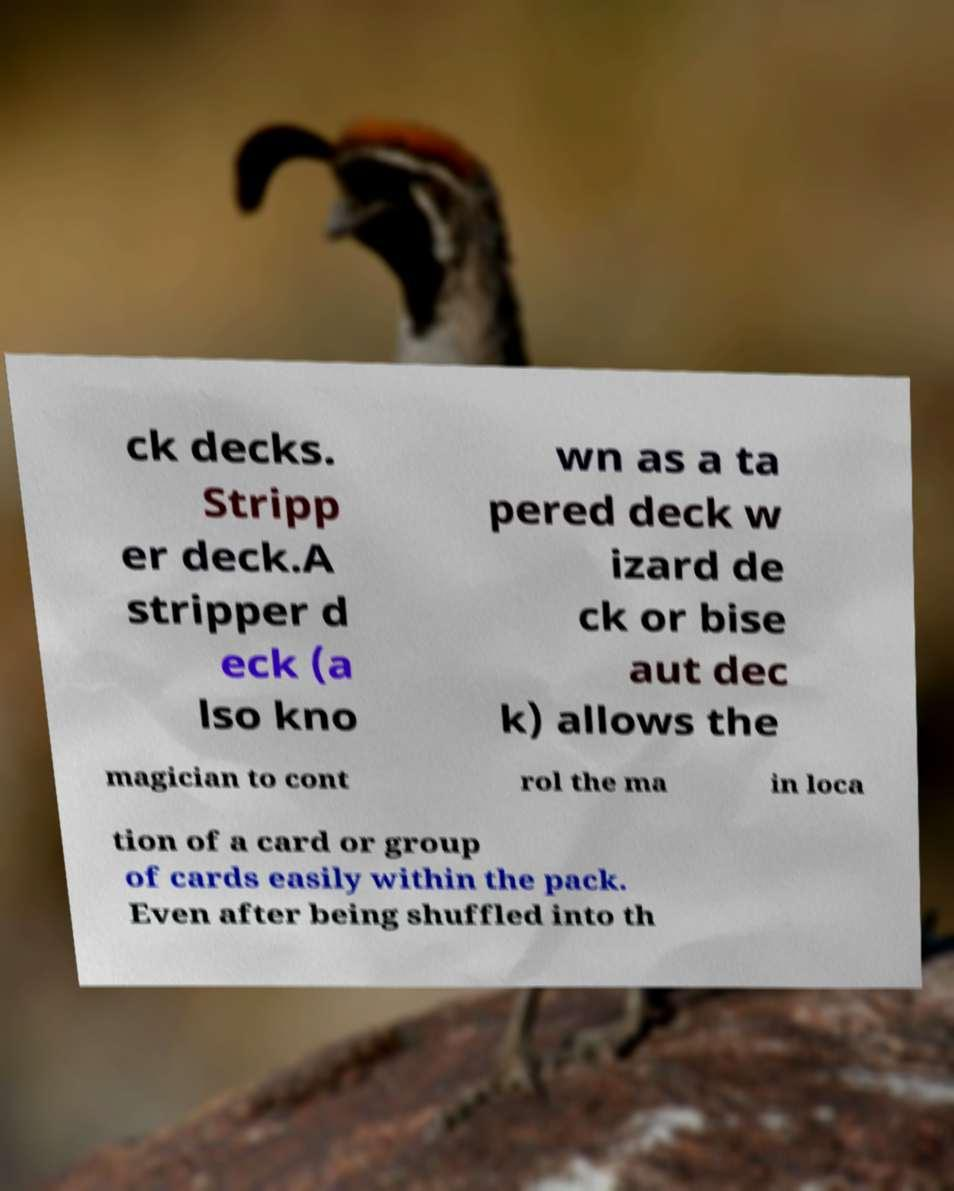Can you read and provide the text displayed in the image?This photo seems to have some interesting text. Can you extract and type it out for me? ck decks. Stripp er deck.A stripper d eck (a lso kno wn as a ta pered deck w izard de ck or bise aut dec k) allows the magician to cont rol the ma in loca tion of a card or group of cards easily within the pack. Even after being shuffled into th 